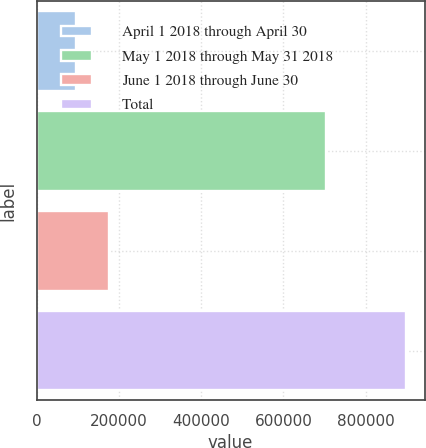Convert chart. <chart><loc_0><loc_0><loc_500><loc_500><bar_chart><fcel>April 1 2018 through April 30<fcel>May 1 2018 through May 31 2018<fcel>June 1 2018 through June 30<fcel>Total<nl><fcel>96100<fcel>704770<fcel>176342<fcel>898517<nl></chart> 